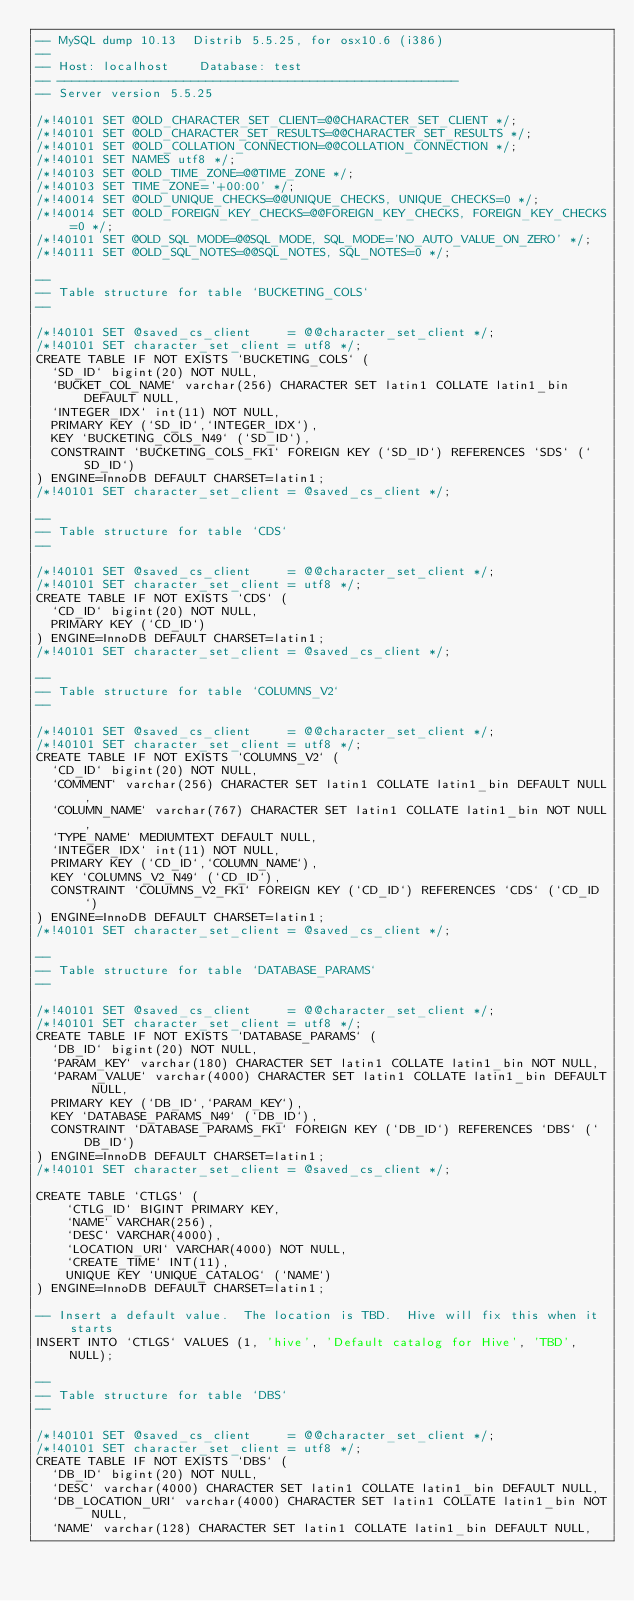Convert code to text. <code><loc_0><loc_0><loc_500><loc_500><_SQL_>-- MySQL dump 10.13  Distrib 5.5.25, for osx10.6 (i386)
--
-- Host: localhost    Database: test
-- ------------------------------------------------------
-- Server version	5.5.25

/*!40101 SET @OLD_CHARACTER_SET_CLIENT=@@CHARACTER_SET_CLIENT */;
/*!40101 SET @OLD_CHARACTER_SET_RESULTS=@@CHARACTER_SET_RESULTS */;
/*!40101 SET @OLD_COLLATION_CONNECTION=@@COLLATION_CONNECTION */;
/*!40101 SET NAMES utf8 */;
/*!40103 SET @OLD_TIME_ZONE=@@TIME_ZONE */;
/*!40103 SET TIME_ZONE='+00:00' */;
/*!40014 SET @OLD_UNIQUE_CHECKS=@@UNIQUE_CHECKS, UNIQUE_CHECKS=0 */;
/*!40014 SET @OLD_FOREIGN_KEY_CHECKS=@@FOREIGN_KEY_CHECKS, FOREIGN_KEY_CHECKS=0 */;
/*!40101 SET @OLD_SQL_MODE=@@SQL_MODE, SQL_MODE='NO_AUTO_VALUE_ON_ZERO' */;
/*!40111 SET @OLD_SQL_NOTES=@@SQL_NOTES, SQL_NOTES=0 */;

--
-- Table structure for table `BUCKETING_COLS`
--

/*!40101 SET @saved_cs_client     = @@character_set_client */;
/*!40101 SET character_set_client = utf8 */;
CREATE TABLE IF NOT EXISTS `BUCKETING_COLS` (
  `SD_ID` bigint(20) NOT NULL,
  `BUCKET_COL_NAME` varchar(256) CHARACTER SET latin1 COLLATE latin1_bin DEFAULT NULL,
  `INTEGER_IDX` int(11) NOT NULL,
  PRIMARY KEY (`SD_ID`,`INTEGER_IDX`),
  KEY `BUCKETING_COLS_N49` (`SD_ID`),
  CONSTRAINT `BUCKETING_COLS_FK1` FOREIGN KEY (`SD_ID`) REFERENCES `SDS` (`SD_ID`)
) ENGINE=InnoDB DEFAULT CHARSET=latin1;
/*!40101 SET character_set_client = @saved_cs_client */;

--
-- Table structure for table `CDS`
--

/*!40101 SET @saved_cs_client     = @@character_set_client */;
/*!40101 SET character_set_client = utf8 */;
CREATE TABLE IF NOT EXISTS `CDS` (
  `CD_ID` bigint(20) NOT NULL,
  PRIMARY KEY (`CD_ID`)
) ENGINE=InnoDB DEFAULT CHARSET=latin1;
/*!40101 SET character_set_client = @saved_cs_client */;

--
-- Table structure for table `COLUMNS_V2`
--

/*!40101 SET @saved_cs_client     = @@character_set_client */;
/*!40101 SET character_set_client = utf8 */;
CREATE TABLE IF NOT EXISTS `COLUMNS_V2` (
  `CD_ID` bigint(20) NOT NULL,
  `COMMENT` varchar(256) CHARACTER SET latin1 COLLATE latin1_bin DEFAULT NULL,
  `COLUMN_NAME` varchar(767) CHARACTER SET latin1 COLLATE latin1_bin NOT NULL,
  `TYPE_NAME` MEDIUMTEXT DEFAULT NULL,
  `INTEGER_IDX` int(11) NOT NULL,
  PRIMARY KEY (`CD_ID`,`COLUMN_NAME`),
  KEY `COLUMNS_V2_N49` (`CD_ID`),
  CONSTRAINT `COLUMNS_V2_FK1` FOREIGN KEY (`CD_ID`) REFERENCES `CDS` (`CD_ID`)
) ENGINE=InnoDB DEFAULT CHARSET=latin1;
/*!40101 SET character_set_client = @saved_cs_client */;

--
-- Table structure for table `DATABASE_PARAMS`
--

/*!40101 SET @saved_cs_client     = @@character_set_client */;
/*!40101 SET character_set_client = utf8 */;
CREATE TABLE IF NOT EXISTS `DATABASE_PARAMS` (
  `DB_ID` bigint(20) NOT NULL,
  `PARAM_KEY` varchar(180) CHARACTER SET latin1 COLLATE latin1_bin NOT NULL,
  `PARAM_VALUE` varchar(4000) CHARACTER SET latin1 COLLATE latin1_bin DEFAULT NULL,
  PRIMARY KEY (`DB_ID`,`PARAM_KEY`),
  KEY `DATABASE_PARAMS_N49` (`DB_ID`),
  CONSTRAINT `DATABASE_PARAMS_FK1` FOREIGN KEY (`DB_ID`) REFERENCES `DBS` (`DB_ID`)
) ENGINE=InnoDB DEFAULT CHARSET=latin1;
/*!40101 SET character_set_client = @saved_cs_client */;

CREATE TABLE `CTLGS` (
    `CTLG_ID` BIGINT PRIMARY KEY,
    `NAME` VARCHAR(256),
    `DESC` VARCHAR(4000),
    `LOCATION_URI` VARCHAR(4000) NOT NULL,
    `CREATE_TIME` INT(11),
    UNIQUE KEY `UNIQUE_CATALOG` (`NAME`)
) ENGINE=InnoDB DEFAULT CHARSET=latin1;

-- Insert a default value.  The location is TBD.  Hive will fix this when it starts
INSERT INTO `CTLGS` VALUES (1, 'hive', 'Default catalog for Hive', 'TBD', NULL);

--
-- Table structure for table `DBS`
--

/*!40101 SET @saved_cs_client     = @@character_set_client */;
/*!40101 SET character_set_client = utf8 */;
CREATE TABLE IF NOT EXISTS `DBS` (
  `DB_ID` bigint(20) NOT NULL,
  `DESC` varchar(4000) CHARACTER SET latin1 COLLATE latin1_bin DEFAULT NULL,
  `DB_LOCATION_URI` varchar(4000) CHARACTER SET latin1 COLLATE latin1_bin NOT NULL,
  `NAME` varchar(128) CHARACTER SET latin1 COLLATE latin1_bin DEFAULT NULL,</code> 